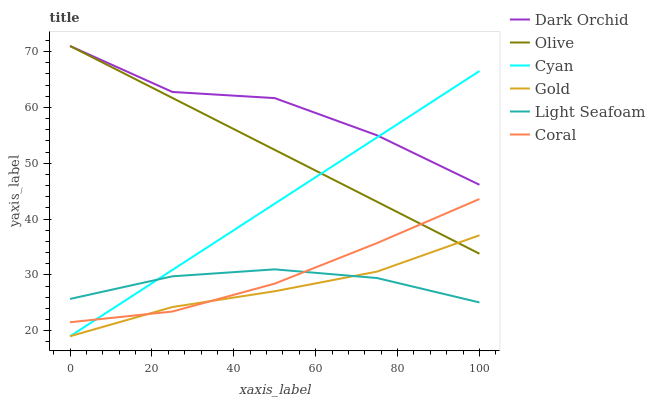Does Gold have the minimum area under the curve?
Answer yes or no. Yes. Does Dark Orchid have the maximum area under the curve?
Answer yes or no. Yes. Does Coral have the minimum area under the curve?
Answer yes or no. No. Does Coral have the maximum area under the curve?
Answer yes or no. No. Is Cyan the smoothest?
Answer yes or no. Yes. Is Dark Orchid the roughest?
Answer yes or no. Yes. Is Coral the smoothest?
Answer yes or no. No. Is Coral the roughest?
Answer yes or no. No. Does Gold have the lowest value?
Answer yes or no. Yes. Does Coral have the lowest value?
Answer yes or no. No. Does Olive have the highest value?
Answer yes or no. Yes. Does Coral have the highest value?
Answer yes or no. No. Is Coral less than Dark Orchid?
Answer yes or no. Yes. Is Dark Orchid greater than Gold?
Answer yes or no. Yes. Does Cyan intersect Gold?
Answer yes or no. Yes. Is Cyan less than Gold?
Answer yes or no. No. Is Cyan greater than Gold?
Answer yes or no. No. Does Coral intersect Dark Orchid?
Answer yes or no. No. 